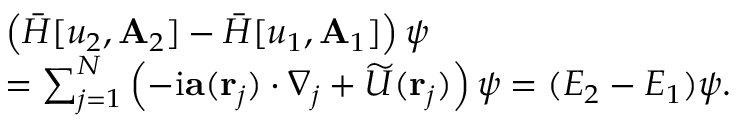Convert formula to latex. <formula><loc_0><loc_0><loc_500><loc_500>\begin{array} { r l } & { \left ( \bar { H } [ u _ { 2 } , A _ { 2 } ] - \bar { H } [ u _ { 1 } , A _ { 1 } ] \right ) \psi } \\ & { = \sum _ { j = 1 } ^ { N } \left ( - i a ( r _ { j } ) \cdot \nabla _ { j } + \widetilde { U } ( r _ { j } ) \right ) \psi = ( E _ { 2 } - E _ { 1 } ) \psi . } \end{array}</formula> 